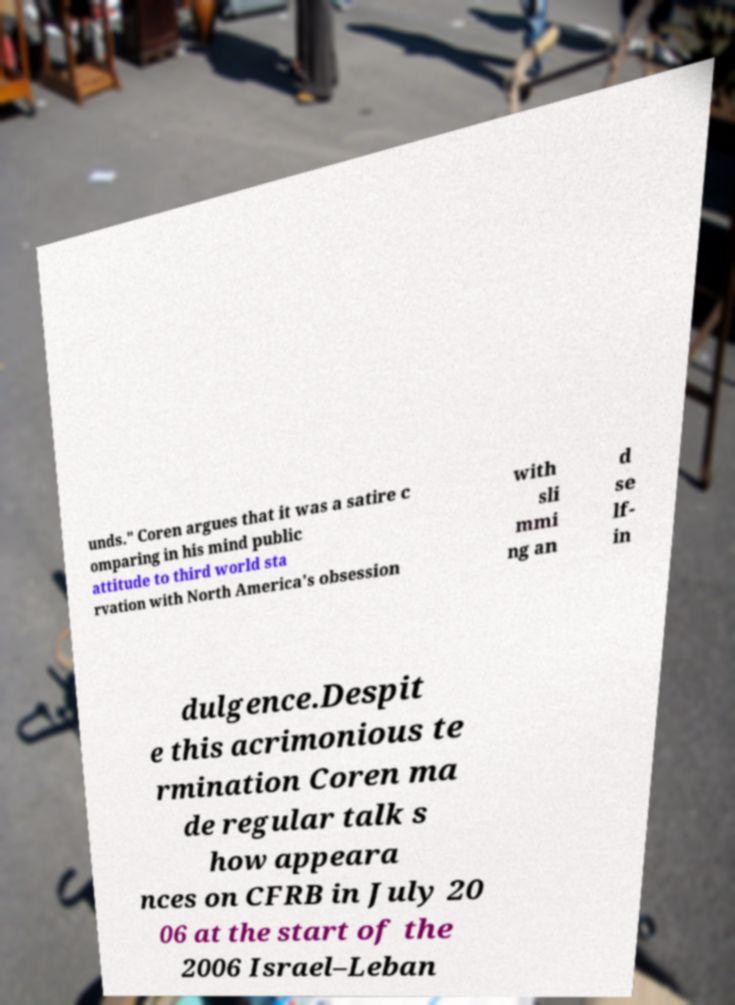There's text embedded in this image that I need extracted. Can you transcribe it verbatim? unds." Coren argues that it was a satire c omparing in his mind public attitude to third world sta rvation with North America's obsession with sli mmi ng an d se lf- in dulgence.Despit e this acrimonious te rmination Coren ma de regular talk s how appeara nces on CFRB in July 20 06 at the start of the 2006 Israel–Leban 